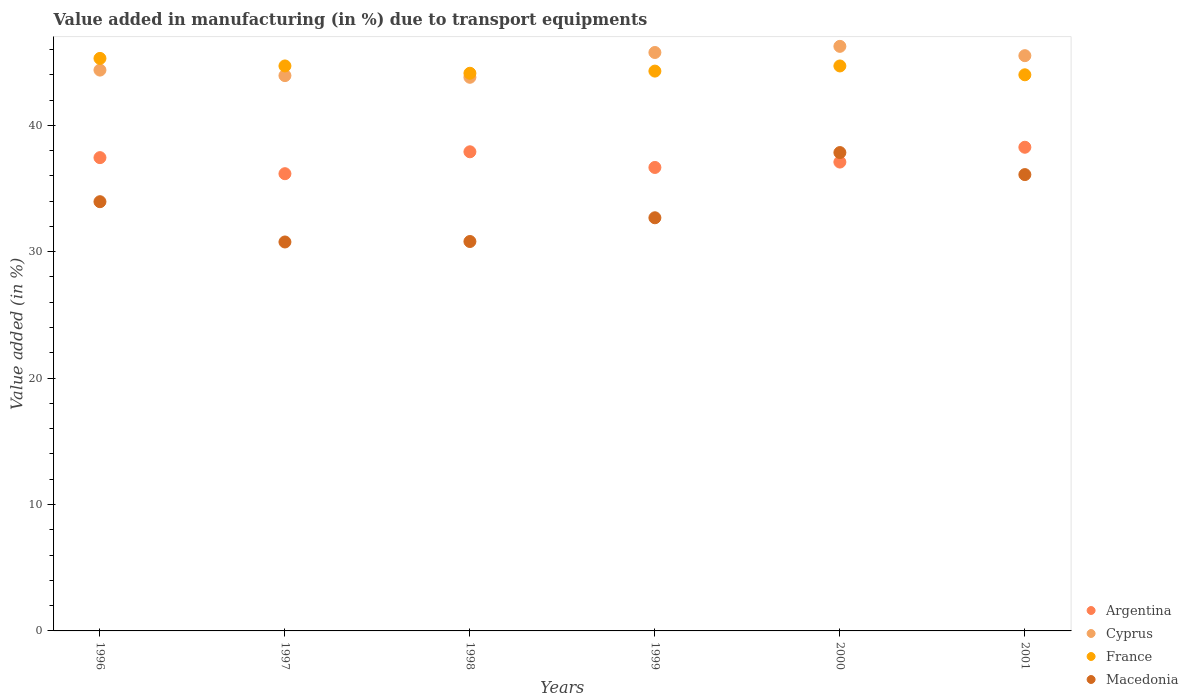Is the number of dotlines equal to the number of legend labels?
Your answer should be compact. Yes. What is the percentage of value added in manufacturing due to transport equipments in France in 2000?
Your response must be concise. 44.7. Across all years, what is the maximum percentage of value added in manufacturing due to transport equipments in France?
Make the answer very short. 45.29. Across all years, what is the minimum percentage of value added in manufacturing due to transport equipments in Argentina?
Provide a short and direct response. 36.17. What is the total percentage of value added in manufacturing due to transport equipments in Macedonia in the graph?
Offer a terse response. 202.17. What is the difference between the percentage of value added in manufacturing due to transport equipments in France in 2000 and that in 2001?
Provide a succinct answer. 0.7. What is the difference between the percentage of value added in manufacturing due to transport equipments in Cyprus in 1998 and the percentage of value added in manufacturing due to transport equipments in France in 1999?
Your answer should be very brief. -0.49. What is the average percentage of value added in manufacturing due to transport equipments in Cyprus per year?
Make the answer very short. 44.94. In the year 1998, what is the difference between the percentage of value added in manufacturing due to transport equipments in Argentina and percentage of value added in manufacturing due to transport equipments in France?
Keep it short and to the point. -6.21. What is the ratio of the percentage of value added in manufacturing due to transport equipments in Macedonia in 1996 to that in 1998?
Make the answer very short. 1.1. Is the difference between the percentage of value added in manufacturing due to transport equipments in Argentina in 1996 and 1997 greater than the difference between the percentage of value added in manufacturing due to transport equipments in France in 1996 and 1997?
Make the answer very short. Yes. What is the difference between the highest and the second highest percentage of value added in manufacturing due to transport equipments in Macedonia?
Keep it short and to the point. 1.74. What is the difference between the highest and the lowest percentage of value added in manufacturing due to transport equipments in France?
Your answer should be very brief. 1.3. In how many years, is the percentage of value added in manufacturing due to transport equipments in France greater than the average percentage of value added in manufacturing due to transport equipments in France taken over all years?
Give a very brief answer. 3. Is the sum of the percentage of value added in manufacturing due to transport equipments in Argentina in 1998 and 2000 greater than the maximum percentage of value added in manufacturing due to transport equipments in Cyprus across all years?
Offer a very short reply. Yes. Is it the case that in every year, the sum of the percentage of value added in manufacturing due to transport equipments in Argentina and percentage of value added in manufacturing due to transport equipments in Cyprus  is greater than the sum of percentage of value added in manufacturing due to transport equipments in Macedonia and percentage of value added in manufacturing due to transport equipments in France?
Your response must be concise. No. Is it the case that in every year, the sum of the percentage of value added in manufacturing due to transport equipments in Macedonia and percentage of value added in manufacturing due to transport equipments in France  is greater than the percentage of value added in manufacturing due to transport equipments in Cyprus?
Your response must be concise. Yes. Is the percentage of value added in manufacturing due to transport equipments in Macedonia strictly greater than the percentage of value added in manufacturing due to transport equipments in France over the years?
Make the answer very short. No. How many dotlines are there?
Your answer should be compact. 4. What is the difference between two consecutive major ticks on the Y-axis?
Your answer should be compact. 10. Does the graph contain grids?
Provide a short and direct response. No. Where does the legend appear in the graph?
Offer a terse response. Bottom right. How are the legend labels stacked?
Your answer should be compact. Vertical. What is the title of the graph?
Ensure brevity in your answer.  Value added in manufacturing (in %) due to transport equipments. Does "Niger" appear as one of the legend labels in the graph?
Give a very brief answer. No. What is the label or title of the X-axis?
Keep it short and to the point. Years. What is the label or title of the Y-axis?
Offer a terse response. Value added (in %). What is the Value added (in %) in Argentina in 1996?
Keep it short and to the point. 37.44. What is the Value added (in %) in Cyprus in 1996?
Ensure brevity in your answer.  44.37. What is the Value added (in %) in France in 1996?
Provide a short and direct response. 45.29. What is the Value added (in %) in Macedonia in 1996?
Offer a very short reply. 33.96. What is the Value added (in %) of Argentina in 1997?
Provide a succinct answer. 36.17. What is the Value added (in %) in Cyprus in 1997?
Offer a very short reply. 43.93. What is the Value added (in %) in France in 1997?
Your answer should be very brief. 44.7. What is the Value added (in %) in Macedonia in 1997?
Ensure brevity in your answer.  30.77. What is the Value added (in %) in Argentina in 1998?
Give a very brief answer. 37.91. What is the Value added (in %) of Cyprus in 1998?
Provide a succinct answer. 43.8. What is the Value added (in %) of France in 1998?
Give a very brief answer. 44.12. What is the Value added (in %) in Macedonia in 1998?
Your response must be concise. 30.81. What is the Value added (in %) in Argentina in 1999?
Your answer should be compact. 36.67. What is the Value added (in %) of Cyprus in 1999?
Offer a very short reply. 45.76. What is the Value added (in %) of France in 1999?
Ensure brevity in your answer.  44.29. What is the Value added (in %) of Macedonia in 1999?
Your answer should be compact. 32.69. What is the Value added (in %) of Argentina in 2000?
Give a very brief answer. 37.09. What is the Value added (in %) in Cyprus in 2000?
Your response must be concise. 46.25. What is the Value added (in %) of France in 2000?
Provide a succinct answer. 44.7. What is the Value added (in %) in Macedonia in 2000?
Make the answer very short. 37.84. What is the Value added (in %) of Argentina in 2001?
Provide a succinct answer. 38.26. What is the Value added (in %) of Cyprus in 2001?
Ensure brevity in your answer.  45.51. What is the Value added (in %) in France in 2001?
Offer a terse response. 44. What is the Value added (in %) in Macedonia in 2001?
Your answer should be compact. 36.1. Across all years, what is the maximum Value added (in %) in Argentina?
Your answer should be compact. 38.26. Across all years, what is the maximum Value added (in %) in Cyprus?
Ensure brevity in your answer.  46.25. Across all years, what is the maximum Value added (in %) in France?
Keep it short and to the point. 45.29. Across all years, what is the maximum Value added (in %) of Macedonia?
Make the answer very short. 37.84. Across all years, what is the minimum Value added (in %) in Argentina?
Your answer should be very brief. 36.17. Across all years, what is the minimum Value added (in %) of Cyprus?
Your answer should be compact. 43.8. Across all years, what is the minimum Value added (in %) in France?
Provide a succinct answer. 44. Across all years, what is the minimum Value added (in %) of Macedonia?
Offer a very short reply. 30.77. What is the total Value added (in %) in Argentina in the graph?
Offer a terse response. 223.55. What is the total Value added (in %) of Cyprus in the graph?
Your response must be concise. 269.62. What is the total Value added (in %) in France in the graph?
Offer a very short reply. 267.09. What is the total Value added (in %) of Macedonia in the graph?
Make the answer very short. 202.17. What is the difference between the Value added (in %) of Argentina in 1996 and that in 1997?
Give a very brief answer. 1.27. What is the difference between the Value added (in %) of Cyprus in 1996 and that in 1997?
Your answer should be compact. 0.44. What is the difference between the Value added (in %) of France in 1996 and that in 1997?
Your response must be concise. 0.6. What is the difference between the Value added (in %) of Macedonia in 1996 and that in 1997?
Provide a short and direct response. 3.19. What is the difference between the Value added (in %) of Argentina in 1996 and that in 1998?
Provide a succinct answer. -0.46. What is the difference between the Value added (in %) of Cyprus in 1996 and that in 1998?
Your answer should be very brief. 0.57. What is the difference between the Value added (in %) in France in 1996 and that in 1998?
Offer a terse response. 1.18. What is the difference between the Value added (in %) in Macedonia in 1996 and that in 1998?
Make the answer very short. 3.15. What is the difference between the Value added (in %) in Argentina in 1996 and that in 1999?
Your answer should be very brief. 0.78. What is the difference between the Value added (in %) of Cyprus in 1996 and that in 1999?
Offer a terse response. -1.39. What is the difference between the Value added (in %) in Macedonia in 1996 and that in 1999?
Ensure brevity in your answer.  1.27. What is the difference between the Value added (in %) in Argentina in 1996 and that in 2000?
Offer a terse response. 0.35. What is the difference between the Value added (in %) in Cyprus in 1996 and that in 2000?
Give a very brief answer. -1.88. What is the difference between the Value added (in %) of France in 1996 and that in 2000?
Give a very brief answer. 0.6. What is the difference between the Value added (in %) of Macedonia in 1996 and that in 2000?
Ensure brevity in your answer.  -3.89. What is the difference between the Value added (in %) in Argentina in 1996 and that in 2001?
Provide a short and direct response. -0.82. What is the difference between the Value added (in %) in Cyprus in 1996 and that in 2001?
Provide a short and direct response. -1.14. What is the difference between the Value added (in %) of France in 1996 and that in 2001?
Your answer should be very brief. 1.3. What is the difference between the Value added (in %) of Macedonia in 1996 and that in 2001?
Give a very brief answer. -2.14. What is the difference between the Value added (in %) of Argentina in 1997 and that in 1998?
Make the answer very short. -1.73. What is the difference between the Value added (in %) in Cyprus in 1997 and that in 1998?
Keep it short and to the point. 0.13. What is the difference between the Value added (in %) in France in 1997 and that in 1998?
Offer a terse response. 0.58. What is the difference between the Value added (in %) in Macedonia in 1997 and that in 1998?
Offer a terse response. -0.04. What is the difference between the Value added (in %) in Argentina in 1997 and that in 1999?
Your answer should be very brief. -0.49. What is the difference between the Value added (in %) of Cyprus in 1997 and that in 1999?
Your answer should be compact. -1.83. What is the difference between the Value added (in %) in France in 1997 and that in 1999?
Keep it short and to the point. 0.41. What is the difference between the Value added (in %) of Macedonia in 1997 and that in 1999?
Make the answer very short. -1.92. What is the difference between the Value added (in %) in Argentina in 1997 and that in 2000?
Provide a succinct answer. -0.92. What is the difference between the Value added (in %) in Cyprus in 1997 and that in 2000?
Offer a very short reply. -2.31. What is the difference between the Value added (in %) of France in 1997 and that in 2000?
Ensure brevity in your answer.  0. What is the difference between the Value added (in %) of Macedonia in 1997 and that in 2000?
Keep it short and to the point. -7.07. What is the difference between the Value added (in %) in Argentina in 1997 and that in 2001?
Give a very brief answer. -2.09. What is the difference between the Value added (in %) in Cyprus in 1997 and that in 2001?
Offer a very short reply. -1.58. What is the difference between the Value added (in %) in France in 1997 and that in 2001?
Your answer should be very brief. 0.7. What is the difference between the Value added (in %) of Macedonia in 1997 and that in 2001?
Your answer should be very brief. -5.33. What is the difference between the Value added (in %) of Argentina in 1998 and that in 1999?
Provide a succinct answer. 1.24. What is the difference between the Value added (in %) in Cyprus in 1998 and that in 1999?
Your response must be concise. -1.96. What is the difference between the Value added (in %) of France in 1998 and that in 1999?
Make the answer very short. -0.17. What is the difference between the Value added (in %) of Macedonia in 1998 and that in 1999?
Give a very brief answer. -1.88. What is the difference between the Value added (in %) of Argentina in 1998 and that in 2000?
Give a very brief answer. 0.81. What is the difference between the Value added (in %) in Cyprus in 1998 and that in 2000?
Keep it short and to the point. -2.45. What is the difference between the Value added (in %) in France in 1998 and that in 2000?
Ensure brevity in your answer.  -0.58. What is the difference between the Value added (in %) of Macedonia in 1998 and that in 2000?
Offer a terse response. -7.04. What is the difference between the Value added (in %) in Argentina in 1998 and that in 2001?
Your response must be concise. -0.36. What is the difference between the Value added (in %) in Cyprus in 1998 and that in 2001?
Provide a short and direct response. -1.71. What is the difference between the Value added (in %) in France in 1998 and that in 2001?
Offer a very short reply. 0.12. What is the difference between the Value added (in %) of Macedonia in 1998 and that in 2001?
Make the answer very short. -5.29. What is the difference between the Value added (in %) of Argentina in 1999 and that in 2000?
Ensure brevity in your answer.  -0.43. What is the difference between the Value added (in %) in Cyprus in 1999 and that in 2000?
Offer a very short reply. -0.49. What is the difference between the Value added (in %) of France in 1999 and that in 2000?
Make the answer very short. -0.41. What is the difference between the Value added (in %) in Macedonia in 1999 and that in 2000?
Provide a succinct answer. -5.16. What is the difference between the Value added (in %) of Argentina in 1999 and that in 2001?
Offer a terse response. -1.6. What is the difference between the Value added (in %) in Cyprus in 1999 and that in 2001?
Ensure brevity in your answer.  0.25. What is the difference between the Value added (in %) of France in 1999 and that in 2001?
Give a very brief answer. 0.29. What is the difference between the Value added (in %) of Macedonia in 1999 and that in 2001?
Keep it short and to the point. -3.42. What is the difference between the Value added (in %) of Argentina in 2000 and that in 2001?
Your response must be concise. -1.17. What is the difference between the Value added (in %) of Cyprus in 2000 and that in 2001?
Give a very brief answer. 0.74. What is the difference between the Value added (in %) of France in 2000 and that in 2001?
Your answer should be very brief. 0.7. What is the difference between the Value added (in %) of Macedonia in 2000 and that in 2001?
Your response must be concise. 1.74. What is the difference between the Value added (in %) of Argentina in 1996 and the Value added (in %) of Cyprus in 1997?
Your answer should be compact. -6.49. What is the difference between the Value added (in %) in Argentina in 1996 and the Value added (in %) in France in 1997?
Your answer should be compact. -7.25. What is the difference between the Value added (in %) of Argentina in 1996 and the Value added (in %) of Macedonia in 1997?
Provide a short and direct response. 6.67. What is the difference between the Value added (in %) of Cyprus in 1996 and the Value added (in %) of France in 1997?
Provide a succinct answer. -0.33. What is the difference between the Value added (in %) in Cyprus in 1996 and the Value added (in %) in Macedonia in 1997?
Ensure brevity in your answer.  13.6. What is the difference between the Value added (in %) in France in 1996 and the Value added (in %) in Macedonia in 1997?
Give a very brief answer. 14.52. What is the difference between the Value added (in %) of Argentina in 1996 and the Value added (in %) of Cyprus in 1998?
Provide a short and direct response. -6.36. What is the difference between the Value added (in %) of Argentina in 1996 and the Value added (in %) of France in 1998?
Ensure brevity in your answer.  -6.67. What is the difference between the Value added (in %) of Argentina in 1996 and the Value added (in %) of Macedonia in 1998?
Your response must be concise. 6.64. What is the difference between the Value added (in %) of Cyprus in 1996 and the Value added (in %) of France in 1998?
Ensure brevity in your answer.  0.25. What is the difference between the Value added (in %) of Cyprus in 1996 and the Value added (in %) of Macedonia in 1998?
Provide a short and direct response. 13.56. What is the difference between the Value added (in %) in France in 1996 and the Value added (in %) in Macedonia in 1998?
Ensure brevity in your answer.  14.49. What is the difference between the Value added (in %) of Argentina in 1996 and the Value added (in %) of Cyprus in 1999?
Your answer should be very brief. -8.32. What is the difference between the Value added (in %) in Argentina in 1996 and the Value added (in %) in France in 1999?
Provide a succinct answer. -6.85. What is the difference between the Value added (in %) in Argentina in 1996 and the Value added (in %) in Macedonia in 1999?
Offer a terse response. 4.76. What is the difference between the Value added (in %) in Cyprus in 1996 and the Value added (in %) in France in 1999?
Give a very brief answer. 0.08. What is the difference between the Value added (in %) of Cyprus in 1996 and the Value added (in %) of Macedonia in 1999?
Your answer should be very brief. 11.68. What is the difference between the Value added (in %) of France in 1996 and the Value added (in %) of Macedonia in 1999?
Provide a short and direct response. 12.61. What is the difference between the Value added (in %) in Argentina in 1996 and the Value added (in %) in Cyprus in 2000?
Your answer should be very brief. -8.8. What is the difference between the Value added (in %) in Argentina in 1996 and the Value added (in %) in France in 2000?
Make the answer very short. -7.25. What is the difference between the Value added (in %) in Argentina in 1996 and the Value added (in %) in Macedonia in 2000?
Give a very brief answer. -0.4. What is the difference between the Value added (in %) of Cyprus in 1996 and the Value added (in %) of France in 2000?
Your answer should be very brief. -0.33. What is the difference between the Value added (in %) in Cyprus in 1996 and the Value added (in %) in Macedonia in 2000?
Provide a succinct answer. 6.52. What is the difference between the Value added (in %) of France in 1996 and the Value added (in %) of Macedonia in 2000?
Offer a very short reply. 7.45. What is the difference between the Value added (in %) in Argentina in 1996 and the Value added (in %) in Cyprus in 2001?
Provide a short and direct response. -8.07. What is the difference between the Value added (in %) of Argentina in 1996 and the Value added (in %) of France in 2001?
Offer a very short reply. -6.55. What is the difference between the Value added (in %) in Argentina in 1996 and the Value added (in %) in Macedonia in 2001?
Make the answer very short. 1.34. What is the difference between the Value added (in %) in Cyprus in 1996 and the Value added (in %) in France in 2001?
Your response must be concise. 0.37. What is the difference between the Value added (in %) in Cyprus in 1996 and the Value added (in %) in Macedonia in 2001?
Give a very brief answer. 8.27. What is the difference between the Value added (in %) of France in 1996 and the Value added (in %) of Macedonia in 2001?
Provide a succinct answer. 9.19. What is the difference between the Value added (in %) in Argentina in 1997 and the Value added (in %) in Cyprus in 1998?
Offer a terse response. -7.63. What is the difference between the Value added (in %) of Argentina in 1997 and the Value added (in %) of France in 1998?
Your answer should be very brief. -7.95. What is the difference between the Value added (in %) in Argentina in 1997 and the Value added (in %) in Macedonia in 1998?
Your answer should be compact. 5.36. What is the difference between the Value added (in %) of Cyprus in 1997 and the Value added (in %) of France in 1998?
Make the answer very short. -0.19. What is the difference between the Value added (in %) in Cyprus in 1997 and the Value added (in %) in Macedonia in 1998?
Your answer should be very brief. 13.12. What is the difference between the Value added (in %) of France in 1997 and the Value added (in %) of Macedonia in 1998?
Offer a very short reply. 13.89. What is the difference between the Value added (in %) of Argentina in 1997 and the Value added (in %) of Cyprus in 1999?
Your answer should be compact. -9.59. What is the difference between the Value added (in %) in Argentina in 1997 and the Value added (in %) in France in 1999?
Your answer should be very brief. -8.12. What is the difference between the Value added (in %) in Argentina in 1997 and the Value added (in %) in Macedonia in 1999?
Provide a succinct answer. 3.49. What is the difference between the Value added (in %) in Cyprus in 1997 and the Value added (in %) in France in 1999?
Keep it short and to the point. -0.36. What is the difference between the Value added (in %) of Cyprus in 1997 and the Value added (in %) of Macedonia in 1999?
Your response must be concise. 11.25. What is the difference between the Value added (in %) of France in 1997 and the Value added (in %) of Macedonia in 1999?
Your answer should be very brief. 12.01. What is the difference between the Value added (in %) of Argentina in 1997 and the Value added (in %) of Cyprus in 2000?
Provide a succinct answer. -10.07. What is the difference between the Value added (in %) in Argentina in 1997 and the Value added (in %) in France in 2000?
Provide a short and direct response. -8.52. What is the difference between the Value added (in %) of Argentina in 1997 and the Value added (in %) of Macedonia in 2000?
Keep it short and to the point. -1.67. What is the difference between the Value added (in %) of Cyprus in 1997 and the Value added (in %) of France in 2000?
Your response must be concise. -0.76. What is the difference between the Value added (in %) in Cyprus in 1997 and the Value added (in %) in Macedonia in 2000?
Your answer should be very brief. 6.09. What is the difference between the Value added (in %) of France in 1997 and the Value added (in %) of Macedonia in 2000?
Keep it short and to the point. 6.85. What is the difference between the Value added (in %) of Argentina in 1997 and the Value added (in %) of Cyprus in 2001?
Make the answer very short. -9.34. What is the difference between the Value added (in %) of Argentina in 1997 and the Value added (in %) of France in 2001?
Offer a terse response. -7.82. What is the difference between the Value added (in %) in Argentina in 1997 and the Value added (in %) in Macedonia in 2001?
Your answer should be compact. 0.07. What is the difference between the Value added (in %) in Cyprus in 1997 and the Value added (in %) in France in 2001?
Offer a very short reply. -0.06. What is the difference between the Value added (in %) of Cyprus in 1997 and the Value added (in %) of Macedonia in 2001?
Offer a very short reply. 7.83. What is the difference between the Value added (in %) of France in 1997 and the Value added (in %) of Macedonia in 2001?
Ensure brevity in your answer.  8.6. What is the difference between the Value added (in %) of Argentina in 1998 and the Value added (in %) of Cyprus in 1999?
Give a very brief answer. -7.86. What is the difference between the Value added (in %) in Argentina in 1998 and the Value added (in %) in France in 1999?
Offer a very short reply. -6.38. What is the difference between the Value added (in %) of Argentina in 1998 and the Value added (in %) of Macedonia in 1999?
Keep it short and to the point. 5.22. What is the difference between the Value added (in %) in Cyprus in 1998 and the Value added (in %) in France in 1999?
Offer a very short reply. -0.49. What is the difference between the Value added (in %) of Cyprus in 1998 and the Value added (in %) of Macedonia in 1999?
Give a very brief answer. 11.11. What is the difference between the Value added (in %) in France in 1998 and the Value added (in %) in Macedonia in 1999?
Give a very brief answer. 11.43. What is the difference between the Value added (in %) in Argentina in 1998 and the Value added (in %) in Cyprus in 2000?
Your answer should be very brief. -8.34. What is the difference between the Value added (in %) in Argentina in 1998 and the Value added (in %) in France in 2000?
Provide a succinct answer. -6.79. What is the difference between the Value added (in %) of Argentina in 1998 and the Value added (in %) of Macedonia in 2000?
Ensure brevity in your answer.  0.06. What is the difference between the Value added (in %) of Cyprus in 1998 and the Value added (in %) of France in 2000?
Your response must be concise. -0.9. What is the difference between the Value added (in %) in Cyprus in 1998 and the Value added (in %) in Macedonia in 2000?
Your answer should be compact. 5.95. What is the difference between the Value added (in %) in France in 1998 and the Value added (in %) in Macedonia in 2000?
Your answer should be very brief. 6.27. What is the difference between the Value added (in %) in Argentina in 1998 and the Value added (in %) in Cyprus in 2001?
Ensure brevity in your answer.  -7.6. What is the difference between the Value added (in %) in Argentina in 1998 and the Value added (in %) in France in 2001?
Make the answer very short. -6.09. What is the difference between the Value added (in %) of Argentina in 1998 and the Value added (in %) of Macedonia in 2001?
Provide a succinct answer. 1.8. What is the difference between the Value added (in %) in Cyprus in 1998 and the Value added (in %) in France in 2001?
Your answer should be very brief. -0.2. What is the difference between the Value added (in %) of Cyprus in 1998 and the Value added (in %) of Macedonia in 2001?
Make the answer very short. 7.7. What is the difference between the Value added (in %) of France in 1998 and the Value added (in %) of Macedonia in 2001?
Your answer should be very brief. 8.02. What is the difference between the Value added (in %) of Argentina in 1999 and the Value added (in %) of Cyprus in 2000?
Provide a short and direct response. -9.58. What is the difference between the Value added (in %) in Argentina in 1999 and the Value added (in %) in France in 2000?
Give a very brief answer. -8.03. What is the difference between the Value added (in %) in Argentina in 1999 and the Value added (in %) in Macedonia in 2000?
Provide a short and direct response. -1.18. What is the difference between the Value added (in %) of Cyprus in 1999 and the Value added (in %) of France in 2000?
Your answer should be compact. 1.06. What is the difference between the Value added (in %) in Cyprus in 1999 and the Value added (in %) in Macedonia in 2000?
Your answer should be compact. 7.92. What is the difference between the Value added (in %) in France in 1999 and the Value added (in %) in Macedonia in 2000?
Your response must be concise. 6.44. What is the difference between the Value added (in %) in Argentina in 1999 and the Value added (in %) in Cyprus in 2001?
Ensure brevity in your answer.  -8.84. What is the difference between the Value added (in %) of Argentina in 1999 and the Value added (in %) of France in 2001?
Ensure brevity in your answer.  -7.33. What is the difference between the Value added (in %) in Argentina in 1999 and the Value added (in %) in Macedonia in 2001?
Your answer should be compact. 0.56. What is the difference between the Value added (in %) of Cyprus in 1999 and the Value added (in %) of France in 2001?
Make the answer very short. 1.76. What is the difference between the Value added (in %) in Cyprus in 1999 and the Value added (in %) in Macedonia in 2001?
Provide a succinct answer. 9.66. What is the difference between the Value added (in %) in France in 1999 and the Value added (in %) in Macedonia in 2001?
Your response must be concise. 8.19. What is the difference between the Value added (in %) in Argentina in 2000 and the Value added (in %) in Cyprus in 2001?
Keep it short and to the point. -8.42. What is the difference between the Value added (in %) of Argentina in 2000 and the Value added (in %) of France in 2001?
Offer a very short reply. -6.9. What is the difference between the Value added (in %) of Argentina in 2000 and the Value added (in %) of Macedonia in 2001?
Ensure brevity in your answer.  0.99. What is the difference between the Value added (in %) in Cyprus in 2000 and the Value added (in %) in France in 2001?
Your answer should be compact. 2.25. What is the difference between the Value added (in %) in Cyprus in 2000 and the Value added (in %) in Macedonia in 2001?
Offer a terse response. 10.15. What is the difference between the Value added (in %) in France in 2000 and the Value added (in %) in Macedonia in 2001?
Your answer should be compact. 8.59. What is the average Value added (in %) of Argentina per year?
Make the answer very short. 37.26. What is the average Value added (in %) of Cyprus per year?
Your answer should be very brief. 44.94. What is the average Value added (in %) of France per year?
Offer a very short reply. 44.52. What is the average Value added (in %) of Macedonia per year?
Keep it short and to the point. 33.69. In the year 1996, what is the difference between the Value added (in %) of Argentina and Value added (in %) of Cyprus?
Provide a succinct answer. -6.92. In the year 1996, what is the difference between the Value added (in %) of Argentina and Value added (in %) of France?
Ensure brevity in your answer.  -7.85. In the year 1996, what is the difference between the Value added (in %) in Argentina and Value added (in %) in Macedonia?
Your response must be concise. 3.49. In the year 1996, what is the difference between the Value added (in %) in Cyprus and Value added (in %) in France?
Your answer should be very brief. -0.93. In the year 1996, what is the difference between the Value added (in %) of Cyprus and Value added (in %) of Macedonia?
Provide a short and direct response. 10.41. In the year 1996, what is the difference between the Value added (in %) in France and Value added (in %) in Macedonia?
Your response must be concise. 11.34. In the year 1997, what is the difference between the Value added (in %) of Argentina and Value added (in %) of Cyprus?
Provide a succinct answer. -7.76. In the year 1997, what is the difference between the Value added (in %) of Argentina and Value added (in %) of France?
Provide a short and direct response. -8.53. In the year 1997, what is the difference between the Value added (in %) of Argentina and Value added (in %) of Macedonia?
Provide a short and direct response. 5.4. In the year 1997, what is the difference between the Value added (in %) of Cyprus and Value added (in %) of France?
Ensure brevity in your answer.  -0.77. In the year 1997, what is the difference between the Value added (in %) of Cyprus and Value added (in %) of Macedonia?
Keep it short and to the point. 13.16. In the year 1997, what is the difference between the Value added (in %) in France and Value added (in %) in Macedonia?
Provide a succinct answer. 13.93. In the year 1998, what is the difference between the Value added (in %) in Argentina and Value added (in %) in Cyprus?
Your answer should be compact. -5.89. In the year 1998, what is the difference between the Value added (in %) of Argentina and Value added (in %) of France?
Ensure brevity in your answer.  -6.21. In the year 1998, what is the difference between the Value added (in %) in Argentina and Value added (in %) in Macedonia?
Keep it short and to the point. 7.1. In the year 1998, what is the difference between the Value added (in %) of Cyprus and Value added (in %) of France?
Give a very brief answer. -0.32. In the year 1998, what is the difference between the Value added (in %) in Cyprus and Value added (in %) in Macedonia?
Your response must be concise. 12.99. In the year 1998, what is the difference between the Value added (in %) in France and Value added (in %) in Macedonia?
Your response must be concise. 13.31. In the year 1999, what is the difference between the Value added (in %) of Argentina and Value added (in %) of Cyprus?
Offer a terse response. -9.1. In the year 1999, what is the difference between the Value added (in %) of Argentina and Value added (in %) of France?
Your answer should be very brief. -7.62. In the year 1999, what is the difference between the Value added (in %) in Argentina and Value added (in %) in Macedonia?
Offer a very short reply. 3.98. In the year 1999, what is the difference between the Value added (in %) in Cyprus and Value added (in %) in France?
Provide a succinct answer. 1.47. In the year 1999, what is the difference between the Value added (in %) of Cyprus and Value added (in %) of Macedonia?
Provide a succinct answer. 13.08. In the year 1999, what is the difference between the Value added (in %) in France and Value added (in %) in Macedonia?
Ensure brevity in your answer.  11.6. In the year 2000, what is the difference between the Value added (in %) of Argentina and Value added (in %) of Cyprus?
Ensure brevity in your answer.  -9.15. In the year 2000, what is the difference between the Value added (in %) of Argentina and Value added (in %) of France?
Provide a succinct answer. -7.6. In the year 2000, what is the difference between the Value added (in %) in Argentina and Value added (in %) in Macedonia?
Your answer should be compact. -0.75. In the year 2000, what is the difference between the Value added (in %) of Cyprus and Value added (in %) of France?
Your response must be concise. 1.55. In the year 2000, what is the difference between the Value added (in %) in Cyprus and Value added (in %) in Macedonia?
Your answer should be very brief. 8.4. In the year 2000, what is the difference between the Value added (in %) of France and Value added (in %) of Macedonia?
Your answer should be very brief. 6.85. In the year 2001, what is the difference between the Value added (in %) in Argentina and Value added (in %) in Cyprus?
Your answer should be compact. -7.25. In the year 2001, what is the difference between the Value added (in %) of Argentina and Value added (in %) of France?
Ensure brevity in your answer.  -5.73. In the year 2001, what is the difference between the Value added (in %) of Argentina and Value added (in %) of Macedonia?
Offer a very short reply. 2.16. In the year 2001, what is the difference between the Value added (in %) of Cyprus and Value added (in %) of France?
Give a very brief answer. 1.51. In the year 2001, what is the difference between the Value added (in %) of Cyprus and Value added (in %) of Macedonia?
Provide a succinct answer. 9.41. In the year 2001, what is the difference between the Value added (in %) in France and Value added (in %) in Macedonia?
Give a very brief answer. 7.9. What is the ratio of the Value added (in %) in Argentina in 1996 to that in 1997?
Ensure brevity in your answer.  1.04. What is the ratio of the Value added (in %) of Cyprus in 1996 to that in 1997?
Provide a short and direct response. 1.01. What is the ratio of the Value added (in %) in France in 1996 to that in 1997?
Offer a very short reply. 1.01. What is the ratio of the Value added (in %) in Macedonia in 1996 to that in 1997?
Offer a terse response. 1.1. What is the ratio of the Value added (in %) of Argentina in 1996 to that in 1998?
Make the answer very short. 0.99. What is the ratio of the Value added (in %) of France in 1996 to that in 1998?
Offer a very short reply. 1.03. What is the ratio of the Value added (in %) of Macedonia in 1996 to that in 1998?
Your answer should be compact. 1.1. What is the ratio of the Value added (in %) of Argentina in 1996 to that in 1999?
Provide a succinct answer. 1.02. What is the ratio of the Value added (in %) in Cyprus in 1996 to that in 1999?
Provide a succinct answer. 0.97. What is the ratio of the Value added (in %) of France in 1996 to that in 1999?
Provide a short and direct response. 1.02. What is the ratio of the Value added (in %) in Macedonia in 1996 to that in 1999?
Provide a succinct answer. 1.04. What is the ratio of the Value added (in %) of Argentina in 1996 to that in 2000?
Your answer should be very brief. 1.01. What is the ratio of the Value added (in %) of Cyprus in 1996 to that in 2000?
Your response must be concise. 0.96. What is the ratio of the Value added (in %) of France in 1996 to that in 2000?
Offer a terse response. 1.01. What is the ratio of the Value added (in %) in Macedonia in 1996 to that in 2000?
Your answer should be compact. 0.9. What is the ratio of the Value added (in %) of Argentina in 1996 to that in 2001?
Provide a succinct answer. 0.98. What is the ratio of the Value added (in %) in Cyprus in 1996 to that in 2001?
Provide a short and direct response. 0.97. What is the ratio of the Value added (in %) of France in 1996 to that in 2001?
Offer a very short reply. 1.03. What is the ratio of the Value added (in %) of Macedonia in 1996 to that in 2001?
Your response must be concise. 0.94. What is the ratio of the Value added (in %) in Argentina in 1997 to that in 1998?
Your answer should be very brief. 0.95. What is the ratio of the Value added (in %) of France in 1997 to that in 1998?
Offer a very short reply. 1.01. What is the ratio of the Value added (in %) of Argentina in 1997 to that in 1999?
Make the answer very short. 0.99. What is the ratio of the Value added (in %) of France in 1997 to that in 1999?
Ensure brevity in your answer.  1.01. What is the ratio of the Value added (in %) in Macedonia in 1997 to that in 1999?
Ensure brevity in your answer.  0.94. What is the ratio of the Value added (in %) in Argentina in 1997 to that in 2000?
Ensure brevity in your answer.  0.98. What is the ratio of the Value added (in %) in France in 1997 to that in 2000?
Provide a succinct answer. 1. What is the ratio of the Value added (in %) of Macedonia in 1997 to that in 2000?
Your answer should be very brief. 0.81. What is the ratio of the Value added (in %) of Argentina in 1997 to that in 2001?
Offer a very short reply. 0.95. What is the ratio of the Value added (in %) of Cyprus in 1997 to that in 2001?
Your answer should be very brief. 0.97. What is the ratio of the Value added (in %) in France in 1997 to that in 2001?
Offer a very short reply. 1.02. What is the ratio of the Value added (in %) of Macedonia in 1997 to that in 2001?
Make the answer very short. 0.85. What is the ratio of the Value added (in %) of Argentina in 1998 to that in 1999?
Your answer should be very brief. 1.03. What is the ratio of the Value added (in %) of Cyprus in 1998 to that in 1999?
Provide a short and direct response. 0.96. What is the ratio of the Value added (in %) of Macedonia in 1998 to that in 1999?
Your answer should be compact. 0.94. What is the ratio of the Value added (in %) of Argentina in 1998 to that in 2000?
Make the answer very short. 1.02. What is the ratio of the Value added (in %) in Cyprus in 1998 to that in 2000?
Make the answer very short. 0.95. What is the ratio of the Value added (in %) of France in 1998 to that in 2000?
Your answer should be compact. 0.99. What is the ratio of the Value added (in %) in Macedonia in 1998 to that in 2000?
Make the answer very short. 0.81. What is the ratio of the Value added (in %) in Argentina in 1998 to that in 2001?
Provide a succinct answer. 0.99. What is the ratio of the Value added (in %) in Cyprus in 1998 to that in 2001?
Provide a succinct answer. 0.96. What is the ratio of the Value added (in %) in Macedonia in 1998 to that in 2001?
Give a very brief answer. 0.85. What is the ratio of the Value added (in %) of Argentina in 1999 to that in 2000?
Your answer should be compact. 0.99. What is the ratio of the Value added (in %) of France in 1999 to that in 2000?
Ensure brevity in your answer.  0.99. What is the ratio of the Value added (in %) of Macedonia in 1999 to that in 2000?
Offer a very short reply. 0.86. What is the ratio of the Value added (in %) of Argentina in 1999 to that in 2001?
Make the answer very short. 0.96. What is the ratio of the Value added (in %) in Cyprus in 1999 to that in 2001?
Ensure brevity in your answer.  1.01. What is the ratio of the Value added (in %) in France in 1999 to that in 2001?
Your answer should be compact. 1.01. What is the ratio of the Value added (in %) in Macedonia in 1999 to that in 2001?
Your response must be concise. 0.91. What is the ratio of the Value added (in %) of Argentina in 2000 to that in 2001?
Your answer should be very brief. 0.97. What is the ratio of the Value added (in %) of Cyprus in 2000 to that in 2001?
Your answer should be compact. 1.02. What is the ratio of the Value added (in %) in France in 2000 to that in 2001?
Your answer should be compact. 1.02. What is the ratio of the Value added (in %) in Macedonia in 2000 to that in 2001?
Your answer should be very brief. 1.05. What is the difference between the highest and the second highest Value added (in %) of Argentina?
Keep it short and to the point. 0.36. What is the difference between the highest and the second highest Value added (in %) of Cyprus?
Your answer should be compact. 0.49. What is the difference between the highest and the second highest Value added (in %) of France?
Give a very brief answer. 0.6. What is the difference between the highest and the second highest Value added (in %) of Macedonia?
Make the answer very short. 1.74. What is the difference between the highest and the lowest Value added (in %) of Argentina?
Provide a succinct answer. 2.09. What is the difference between the highest and the lowest Value added (in %) of Cyprus?
Your answer should be compact. 2.45. What is the difference between the highest and the lowest Value added (in %) of France?
Give a very brief answer. 1.3. What is the difference between the highest and the lowest Value added (in %) of Macedonia?
Your answer should be compact. 7.07. 